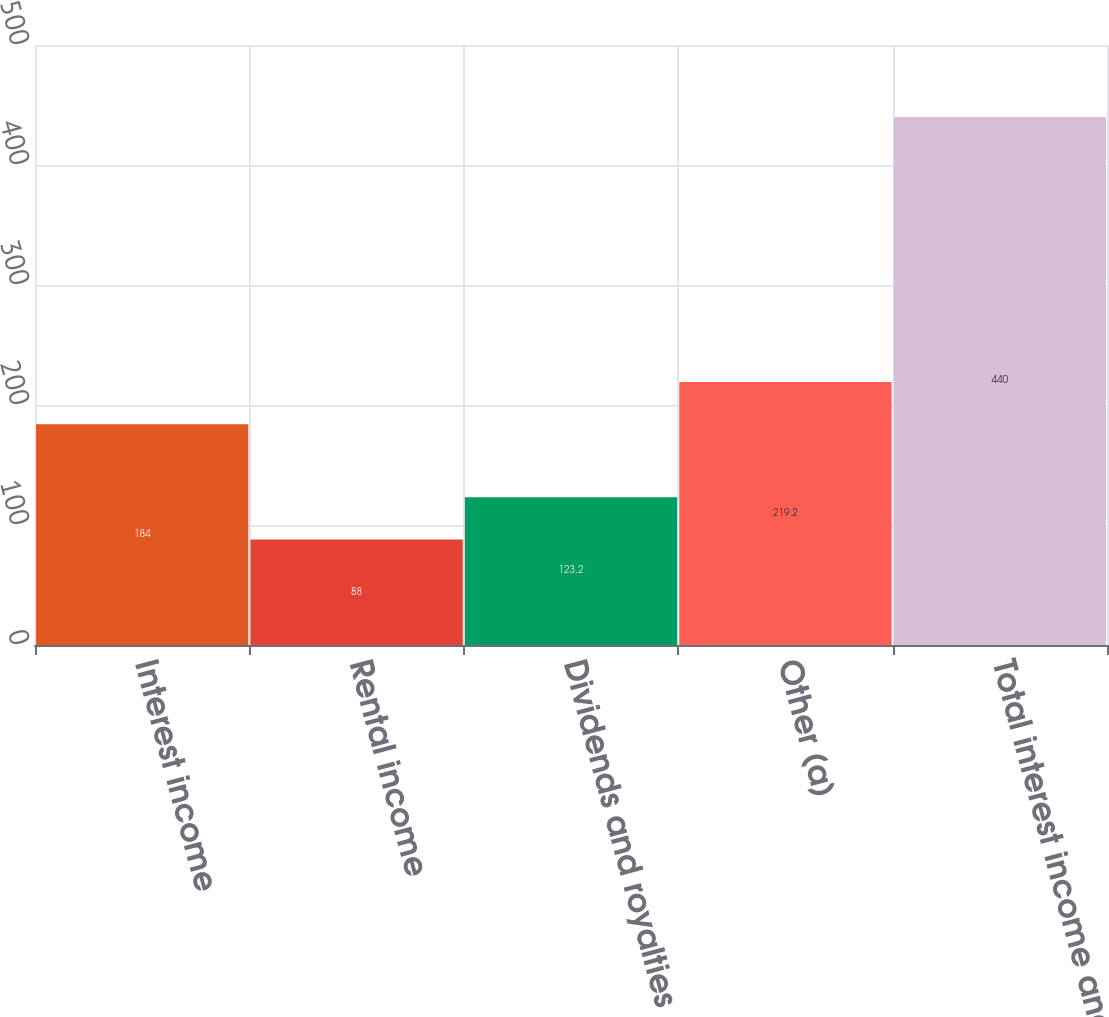Convert chart. <chart><loc_0><loc_0><loc_500><loc_500><bar_chart><fcel>Interest income<fcel>Rental income<fcel>Dividends and royalties<fcel>Other (a)<fcel>Total interest income and<nl><fcel>184<fcel>88<fcel>123.2<fcel>219.2<fcel>440<nl></chart> 